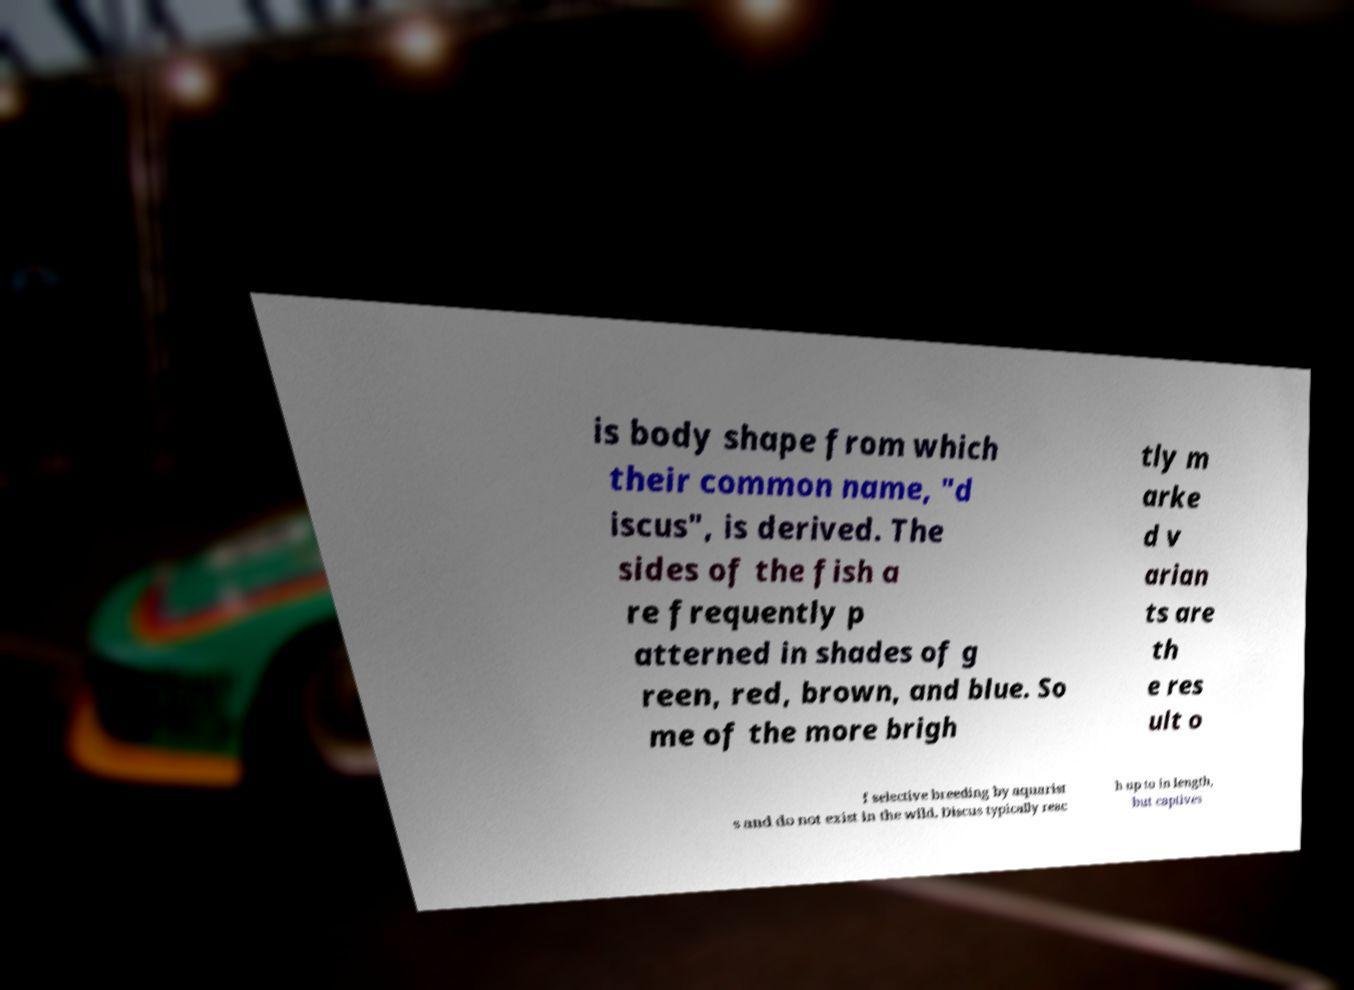What messages or text are displayed in this image? I need them in a readable, typed format. is body shape from which their common name, "d iscus", is derived. The sides of the fish a re frequently p atterned in shades of g reen, red, brown, and blue. So me of the more brigh tly m arke d v arian ts are th e res ult o f selective breeding by aquarist s and do not exist in the wild. Discus typically reac h up to in length, but captives 